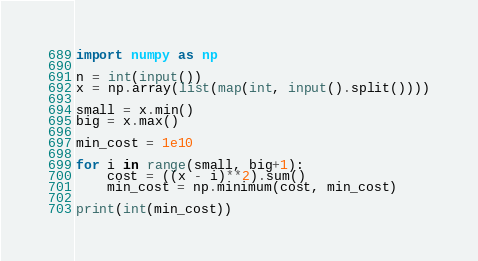<code> <loc_0><loc_0><loc_500><loc_500><_Python_>import numpy as np

n = int(input())
x = np.array(list(map(int, input().split())))

small = x.min()
big = x.max()

min_cost = 1e10

for i in range(small, big+1):
    cost = ((x - i)**2).sum()
    min_cost = np.minimum(cost, min_cost)

print(int(min_cost))</code> 